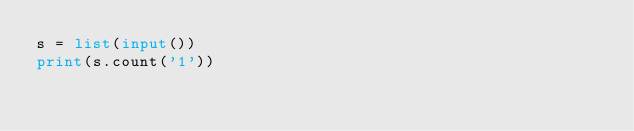<code> <loc_0><loc_0><loc_500><loc_500><_Python_>s = list(input())
print(s.count('1'))</code> 